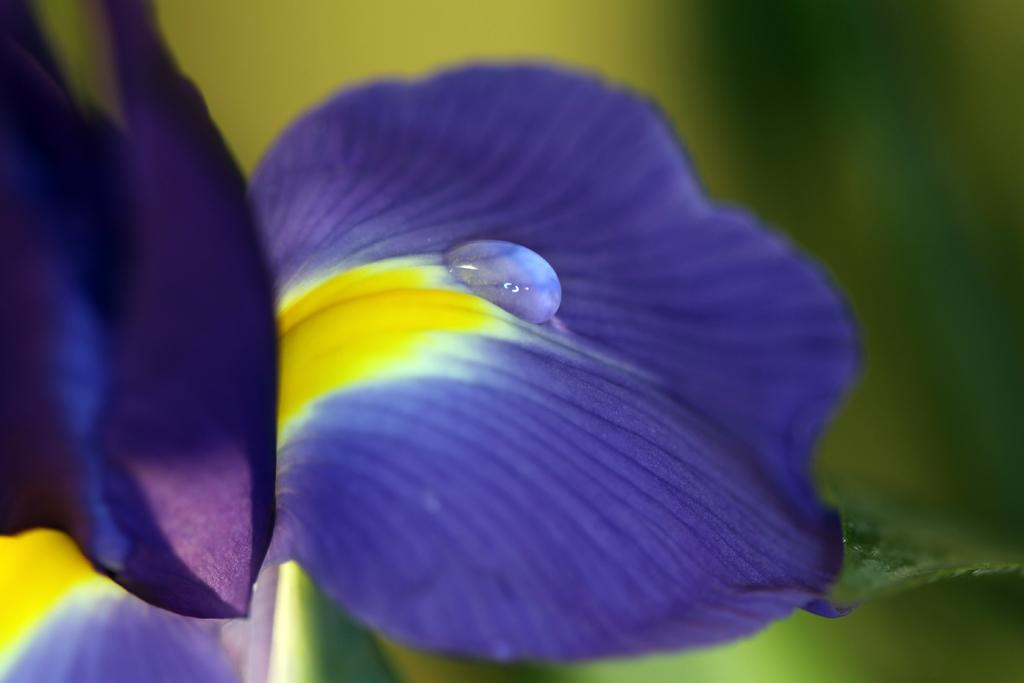What is the main subject of the image? The main subject of the image is a drop of water on a flower petal. Can you describe the location of the drop of water? The drop of water is located on a flower petal in the image. How many sisters are present in the image? There are no sisters present in the image; it features a drop of water on a flower petal. What type of sail can be seen in the image? There is no sail present in the image; it features a drop of water on a flower petal. 